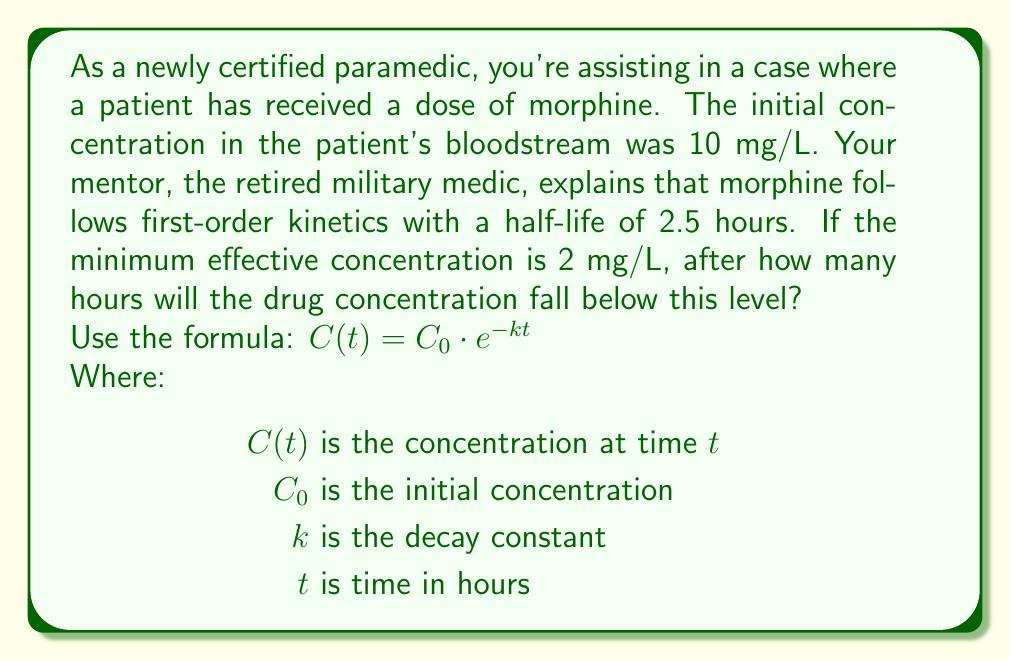Can you answer this question? To solve this problem, we'll follow these steps:

1) First, we need to calculate the decay constant $k$ using the half-life:

   $t_{1/2} = \frac{\ln(2)}{k}$
   $k = \frac{\ln(2)}{t_{1/2}} = \frac{\ln(2)}{2.5} = 0.2773$ per hour

2) Now we can use the exponential decay formula:

   $C(t) = C_0 \cdot e^{-kt}$

3) We want to find $t$ when $C(t) = 2$ mg/L:

   $2 = 10 \cdot e^{-0.2773t}$

4) Divide both sides by 10:

   $0.2 = e^{-0.2773t}$

5) Take the natural log of both sides:

   $\ln(0.2) = -0.2773t$

6) Solve for $t$:

   $t = \frac{\ln(0.2)}{-0.2773} = 5.80$ hours

Therefore, it will take approximately 5.80 hours for the morphine concentration to fall below the minimum effective concentration.
Answer: 5.80 hours 